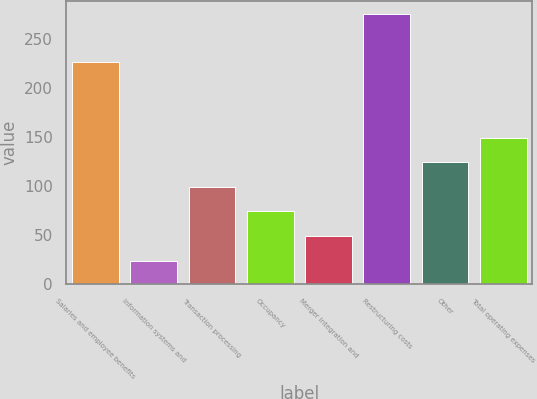Convert chart. <chart><loc_0><loc_0><loc_500><loc_500><bar_chart><fcel>Salaries and employee benefits<fcel>Information systems and<fcel>Transaction processing<fcel>Occupancy<fcel>Merger integration and<fcel>Restructuring costs<fcel>Other<fcel>Total operating expenses<nl><fcel>226<fcel>24<fcel>99.3<fcel>74.2<fcel>49.1<fcel>275<fcel>124.4<fcel>149.5<nl></chart> 